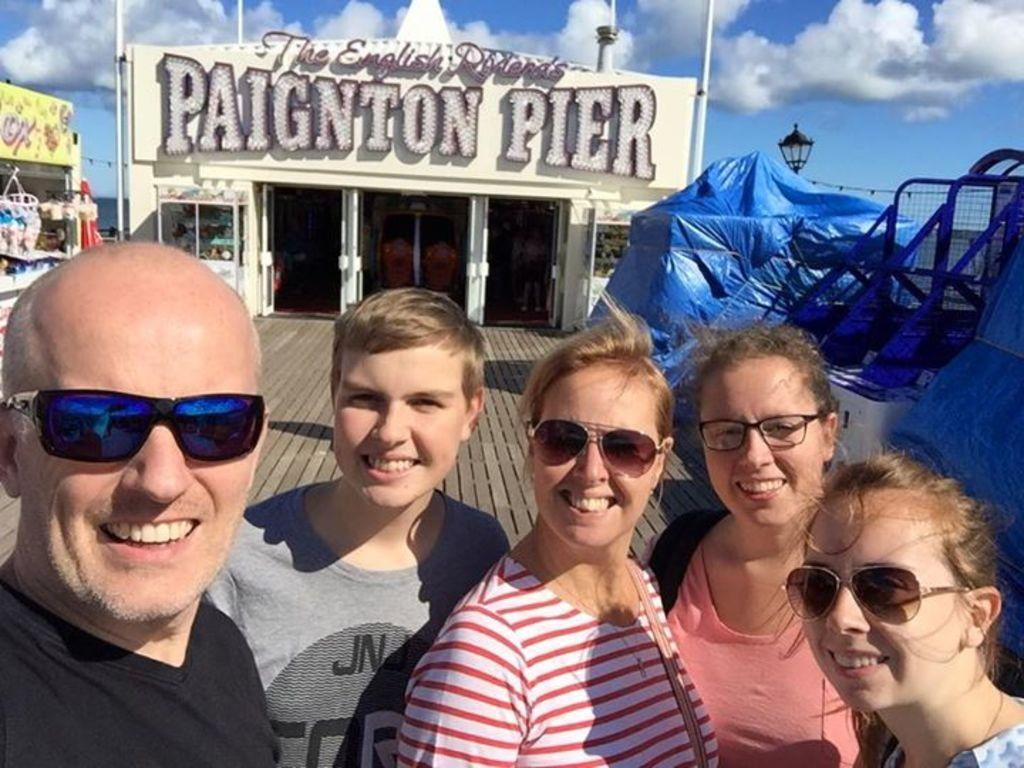What can be seen in the foreground of the image? There is a group of people standing in the front of the image. What type of structures are present in the image? There are buildings in the image. What might be providing shade or protection from the elements in the image? There is a cover, possibly an umbrella or awning, in the image. What type of lighting is present in the image? There is a street lamp in the image. What is visible in the background of the image? The sky is visible in the image, and there are clouds in the sky. What type of education is being provided to the people in the image? There is no indication of education being provided in the image; it simply shows a group of people standing in front of buildings. How does the image change from day to night? The image is a static representation and does not change from day to night. 